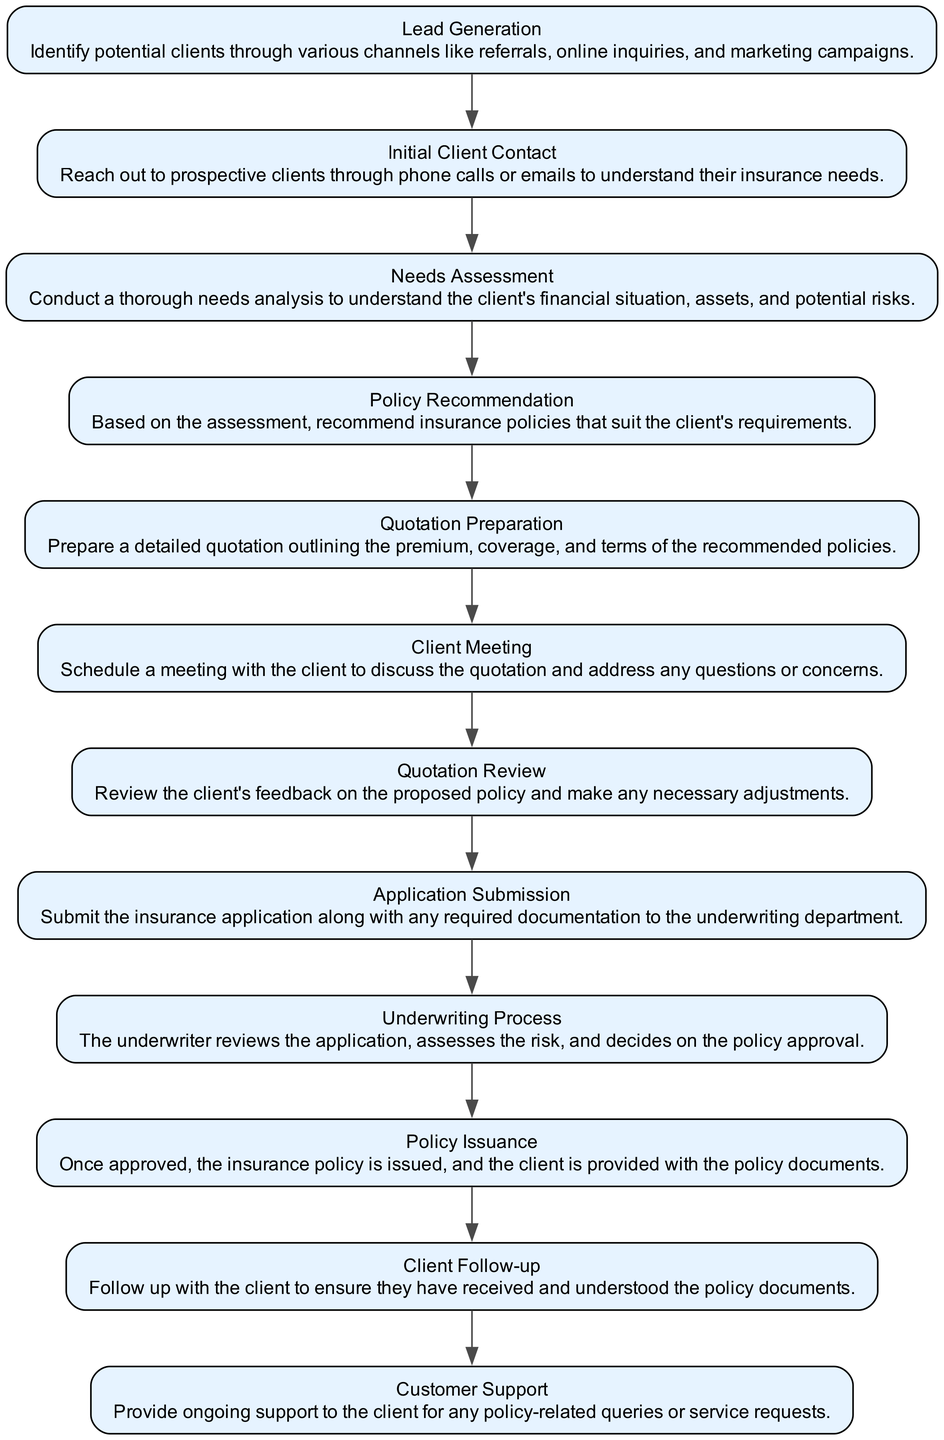What is the first step in the workflow? The first step in the workflow is labeled as "Lead Generation," which is the starting point for identifying potential clients through various channels.
Answer: Lead Generation How many total steps are in the workflow? By counting the nodes in the diagram, we see there are twelve steps, from "Lead Generation" to "Customer Support."
Answer: 12 What follows "Needs Assessment" in the workflow? After "Needs Assessment," the next step is "Policy Recommendation," indicating that the workflow progresses to recommending policies based on the client's needs.
Answer: Policy Recommendation Which step involves submitting documentation? The step that involves submitting documentation is "Application Submission," where the insurance application and required documents are submitted to underwriters.
Answer: Application Submission What is the relationship between "Quotation Review" and "Client Meeting"? "Quotation Review" and "Client Meeting" are consecutive steps; the workflow indicates that after discussing the quotation in the client meeting, the client's feedback is reviewed for adjustments.
Answer: Consecutive steps At what stage does the client receive the policy documents? The client receives the policy documents during the "Policy Issuance" stage after the underwriting process approves the policy.
Answer: Policy Issuance How does the workflow end? The workflow concludes with "Customer Support," indicating that ongoing support is provided to the client after issuing the policy.
Answer: Customer Support Which step directly precedes the "Underwriting Process"? The step that directly precedes the "Underwriting Process" is "Application Submission," suggesting that the underwriting begins after the application is submitted.
Answer: Application Submission What action takes place during "Client Follow-up"? During "Client Follow-up," the action involves ensuring that the client has received and understood the policy documents provided earlier.
Answer: Ensuring understanding of documents 